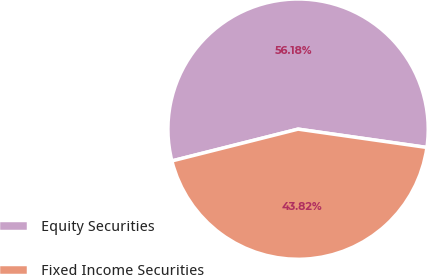Convert chart to OTSL. <chart><loc_0><loc_0><loc_500><loc_500><pie_chart><fcel>Equity Securities<fcel>Fixed Income Securities<nl><fcel>56.18%<fcel>43.82%<nl></chart> 